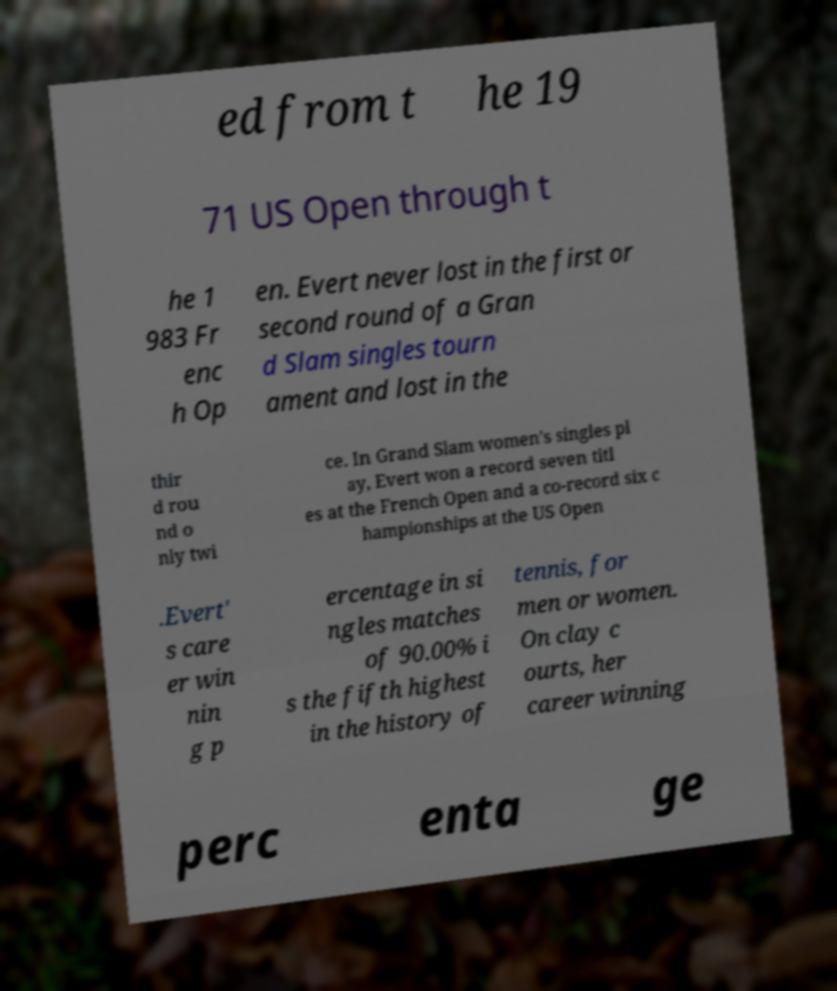For documentation purposes, I need the text within this image transcribed. Could you provide that? ed from t he 19 71 US Open through t he 1 983 Fr enc h Op en. Evert never lost in the first or second round of a Gran d Slam singles tourn ament and lost in the thir d rou nd o nly twi ce. In Grand Slam women's singles pl ay, Evert won a record seven titl es at the French Open and a co-record six c hampionships at the US Open .Evert' s care er win nin g p ercentage in si ngles matches of 90.00% i s the fifth highest in the history of tennis, for men or women. On clay c ourts, her career winning perc enta ge 